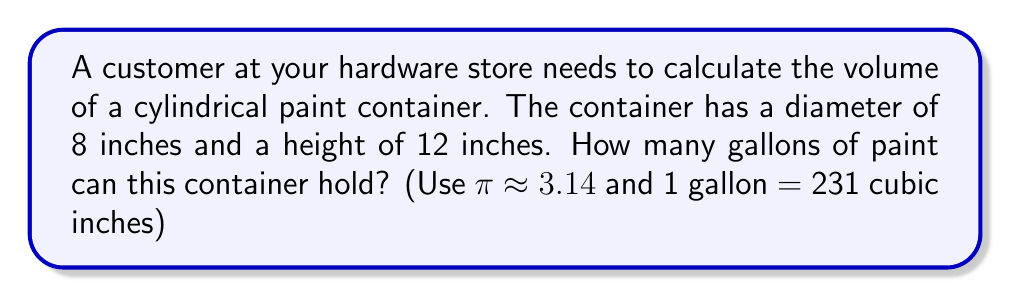Can you solve this math problem? To solve this problem, we'll follow these steps:

1. Calculate the radius of the base:
   The diameter is 8 inches, so the radius is half of that:
   $r = 8 \div 2 = 4$ inches

2. Calculate the volume of the cylinder using the formula:
   $V = \pi r^2 h$
   Where:
   $V$ is the volume
   $r$ is the radius of the base
   $h$ is the height of the cylinder

3. Substitute the values:
   $V = 3.14 \times 4^2 \times 12$

4. Simplify:
   $V = 3.14 \times 16 \times 12 = 602.88$ cubic inches

5. Convert cubic inches to gallons:
   We know that 1 gallon = 231 cubic inches
   So, we divide our result by 231:
   $602.88 \div 231 \approx 2.61$ gallons

Therefore, the cylindrical container can hold approximately 2.61 gallons of paint.
Answer: 2.61 gallons 